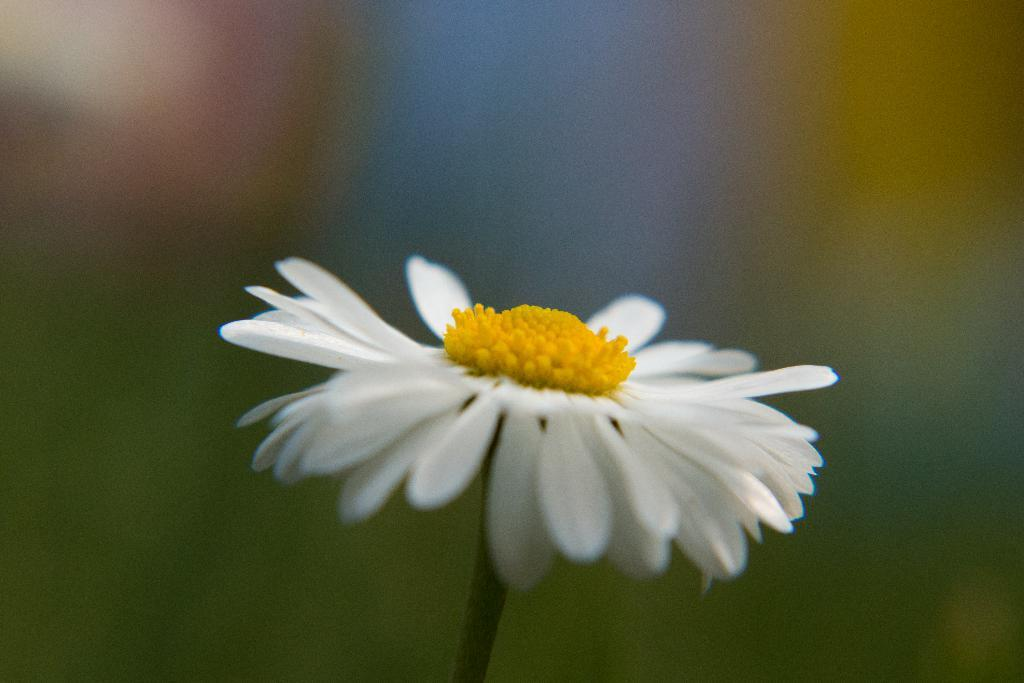What is the main subject of the image? There is a flower in the image. Can you describe the flower's structure? The flower has a stem, and its petals are white. What color is the center of the flower? The middle part of the flower is yellow. How would you describe the background of the image? The background of the image is blurred. What is the profit margin of the flower in the image? There is no information about the profit margin of the flower in the image, as it is a photograph and not a business transaction. 